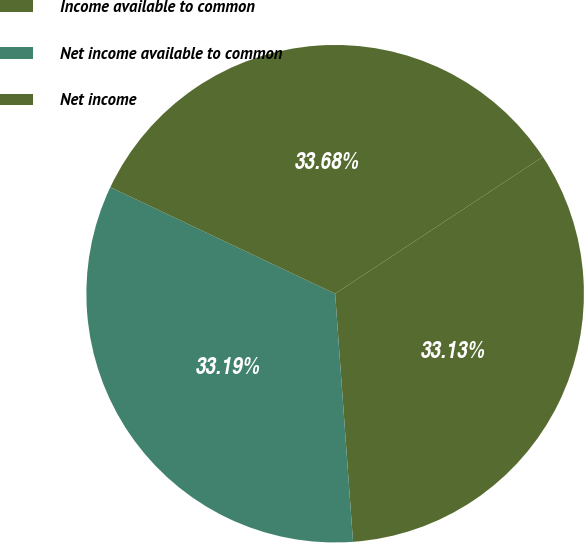<chart> <loc_0><loc_0><loc_500><loc_500><pie_chart><fcel>Income available to common<fcel>Net income available to common<fcel>Net income<nl><fcel>33.13%<fcel>33.19%<fcel>33.68%<nl></chart> 